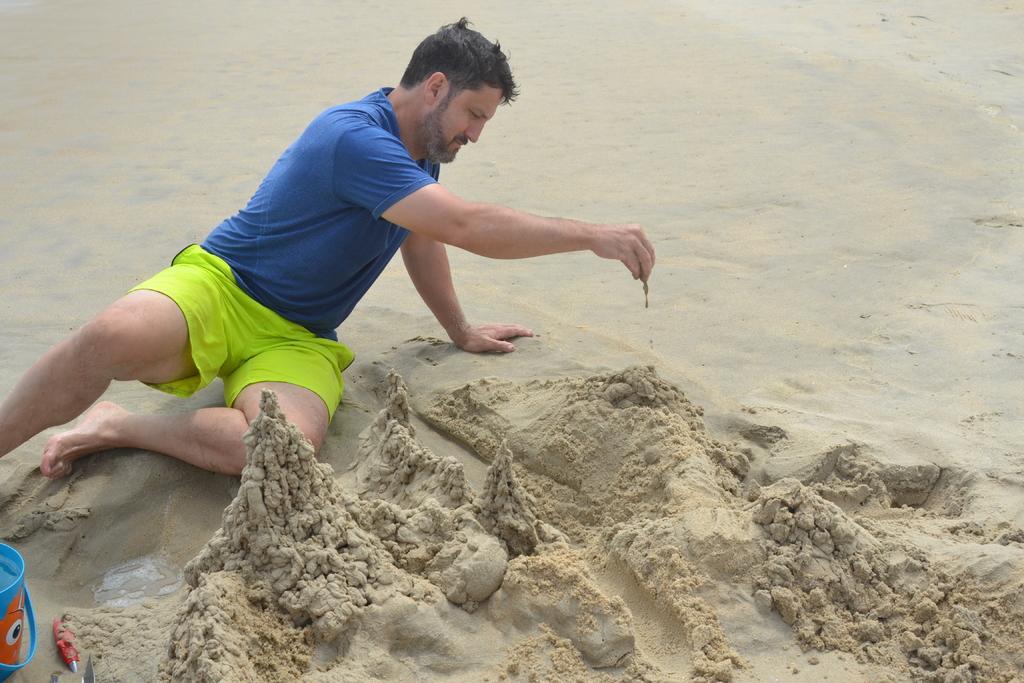Describe this image in one or two sentences. This image consists of a man wearing a blue T-shirt and a green short is sitting on the sand. And he is playing with the sand. On the left, we can see a bucket. At the bottom, there is sand. 